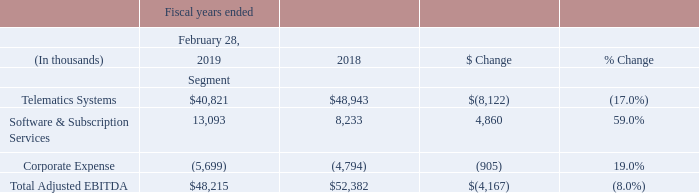Profitability Measures
Net Income:
Our net income in the fiscal year ended February 28, 2019 was $18.4 million as compared to net income of $16.6 million in the same period last year. The increase is due to a $11.7 million increase in operating income, $3.0 million increase in investment income and $12.0 million decrease in income tax provision. The increase in operating income was primarily attributable to $21.0 million decrease in general and administrative expense due to reduced legal provision and related costs as further discussed in Note 19 and partially offset by $8.0 million of restructuring expense.
Adjusted EBITDA for Telematics Systems in the fiscal year ended February 28, 2019 decreased $8.1 million compared to the same period last year due to lower revenues as described above and the impact of high margin revenue earned on a strategic technology partnership arrangement in fiscal 2018. These factors were coupled with higher operating expenses in Telematics Systems as a result of increased headcount and outsourced professional service fees. Adjusted EBITDA for Software and Subscription Services increased $4.9 million compared to the same period last year due primarily to continued growth in revenues and gross profit from our Italia market and higher gross profit from our fleet management services.
See Note 20 for reconciliation of Adjusted EBITDA by reportable segments and a reconciliation to GAAP-basis net income (loss).
What was the Total Adjusted EBITDA for the fiscal year ended February 28, 2018?
Answer scale should be: thousand. 52,382. What were other factors that caused the decrease in adjusted EBITDA for Telematics Systems other than lower revenues and impact of high margin revenue earned? Increased headcount and outsourced professional service fees. What was the Total Adjusted EBITDA for the fiscal year ended February 28, 2019?
Answer scale should be: thousand. 48,215. What is the total Adjusted EBITDA for Telematics Systems and Software & Subscription Services in 2019? 
Answer scale should be: thousand. (40,821+13,093)
Answer: 53914. What is the total Adjusted EBITDA for Telematics Systems and Software & Subscription Services in 2018?
Answer scale should be: thousand. (48,943+8,233)
Answer: 57176. What was the average Corporate Expense for both years, 2018 and 2019?
Answer scale should be: thousand. (-5,699-4,794)/(2019-2018+1)
Answer: -5246.5. 